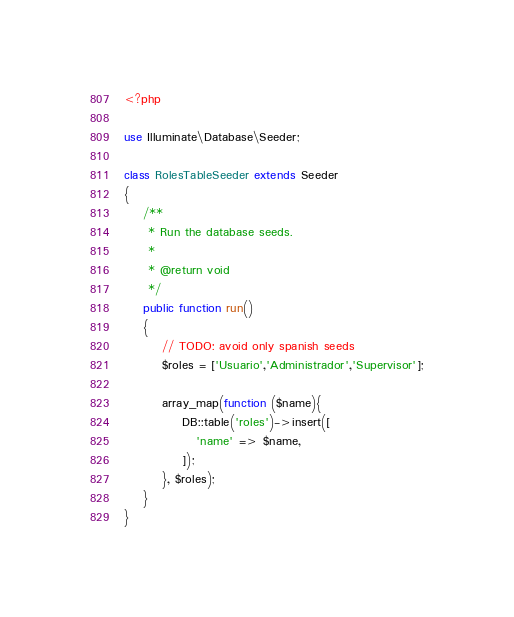Convert code to text. <code><loc_0><loc_0><loc_500><loc_500><_PHP_><?php

use Illuminate\Database\Seeder;

class RolesTableSeeder extends Seeder
{
    /**
     * Run the database seeds.
     *
     * @return void
     */
    public function run()
    {
        // TODO: avoid only spanish seeds
        $roles = ['Usuario','Administrador','Supervisor'];

        array_map(function ($name){
            DB::table('roles')->insert([
               'name' => $name,
            ]);
        }, $roles);
    }
}
</code> 